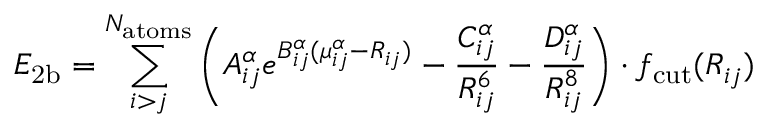Convert formula to latex. <formula><loc_0><loc_0><loc_500><loc_500>E _ { 2 b } = \sum _ { i > j } ^ { N _ { a t o m s } } \left ( A _ { i j } ^ { \alpha } e ^ { B _ { i j } ^ { \alpha } ( \mu _ { i j } ^ { \alpha } - R _ { i j } ) } - \frac { C _ { i j } ^ { \alpha } } { R _ { i j } ^ { 6 } } - \frac { D _ { i j } ^ { \alpha } } { R _ { i j } ^ { 8 } } \right ) \cdot f _ { c u t } ( R _ { i j } )</formula> 